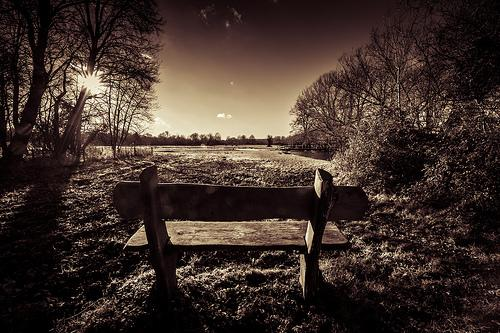In a poetic manner, describe the main object and the surrounding environment in the image. Upon a sea of emerald grass sits a quiet wooden bench, embraced by the sun's warm touch and the silent symphony of barren trees and lush bushes. What are the most striking features of this image? The sunlit wooden bench surrounded by bare trees, the small white cloud in the sky, and the interplay of light and shadow on the grassy field. Using descriptive adjectives, characterize the key components and overall ambiance of the image. An inviting wooden bench rests gracefully on a sun-kissed, verdant field, surrounded by somber, leafless trees, lush bushes, and a tiny, lazy cloud floating above. Briefly describe how light plays a role in this image's composition. Sunlight permeates the scene, casting light and shadow on the grassy field and highlighting the wooden bench, the barren trees, and the bushy undergrowth. Provide a concise description of the scene captured in the image. A wooden bench with visible legs and back rests on a grassy field, surrounded by bare trees, bushes, and sun shining through the trees. Enumerate the key components present in the image. Wooden bench, grass, bare trees, bushes, sun shining, small white cloud, light and shadow. Write a simple sentence that encapsulates the essence of the image. The image depicts a sunlit wooden bench sitting amidst a green field with bare trees, bushes, and a small white cloud in the sky. Briefly describe the primary elements and the atmosphere in the picture. The image shows a sunlit wooden bench on grass, with leafless trees, green bushes, and a tiny white cloud in the sky setting a serene atmosphere. Mention the most important object in the image and describe its surroundings. The wooden bench serves as the focal object, as it sits on grass surrounded by sunlit bare trees, lush bushes, and a singular small cloud in the sky. Describe the image in a way that evokes a sense of peace and tranquility. Underneath the watchful eye of a single white cloud, a lonely wooden bench basks in the sun's embrace, encircled by a tranquil forest of empty branches and vibrant greens. 